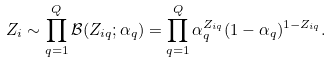Convert formula to latex. <formula><loc_0><loc_0><loc_500><loc_500>Z _ { i } \sim \prod _ { q = 1 } ^ { Q } \mathcal { B } ( Z _ { i q } ; \alpha _ { q } ) = \prod _ { q = 1 } ^ { Q } \alpha _ { q } ^ { Z _ { i q } } ( 1 - \alpha _ { q } ) ^ { 1 - Z _ { i q } } .</formula> 